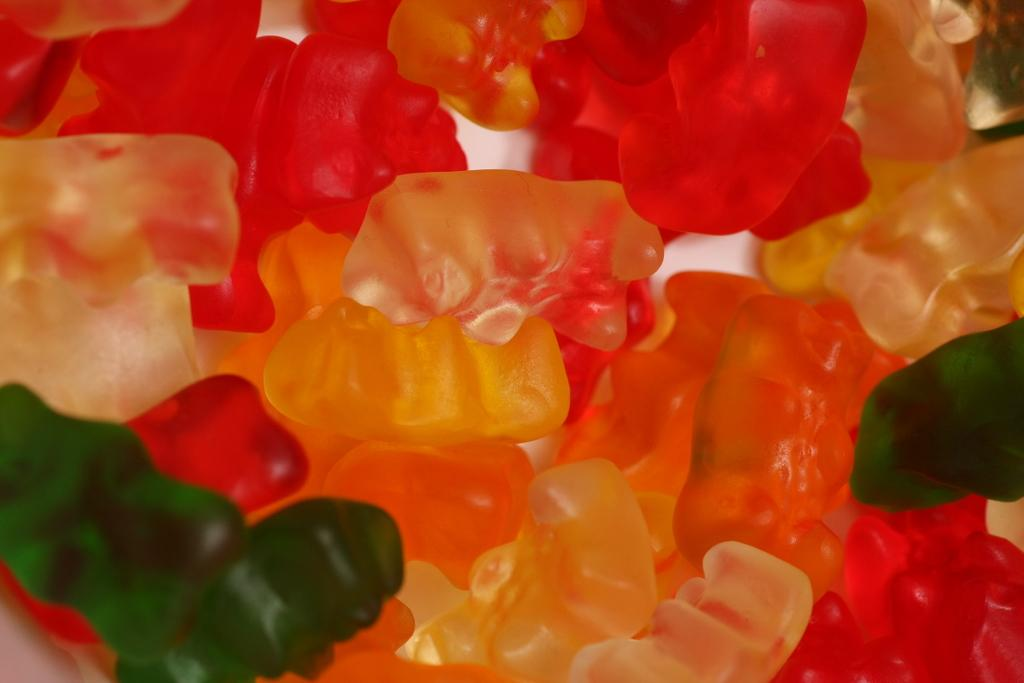What type of food is visible in the image? There are jellies in the image. What is the opinion of the alarm about the jellies in the image? There is no alarm present in the image, so it cannot have an opinion about the jellies. 